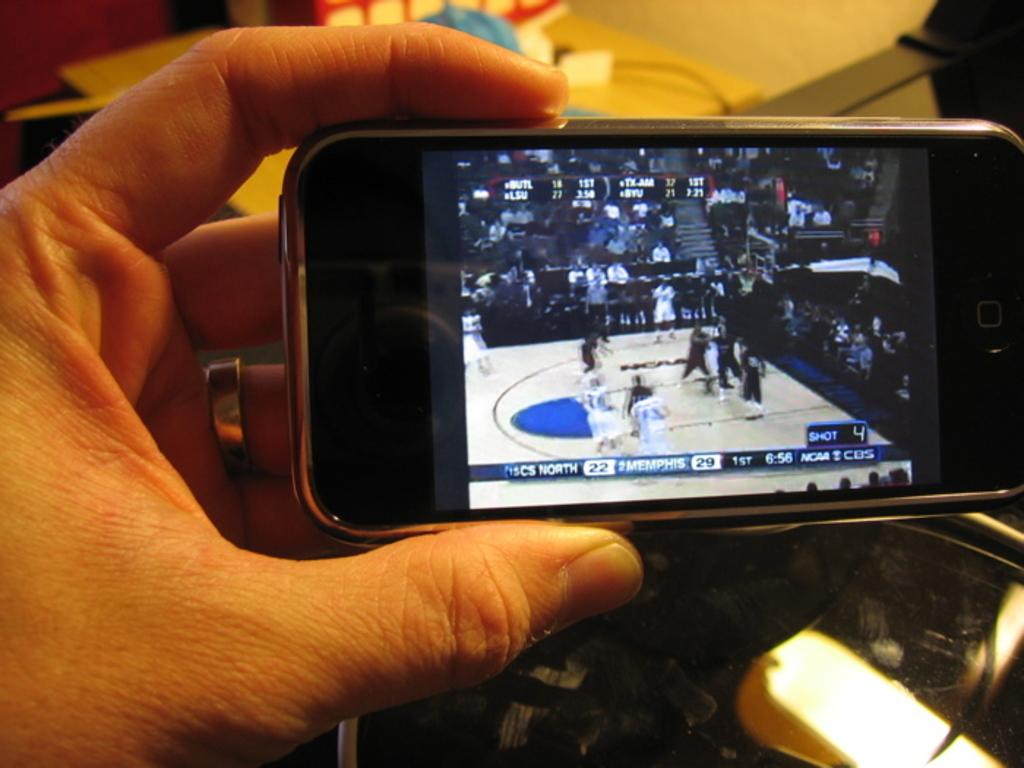Provide a one-sentence caption for the provided image. A phone screen displays a basketball game between Memphis and CS North. 